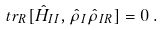Convert formula to latex. <formula><loc_0><loc_0><loc_500><loc_500>t r _ { R } [ \hat { H } _ { I I } , \hat { \rho } _ { I } \hat { \rho } _ { I R } ] = 0 \, .</formula> 